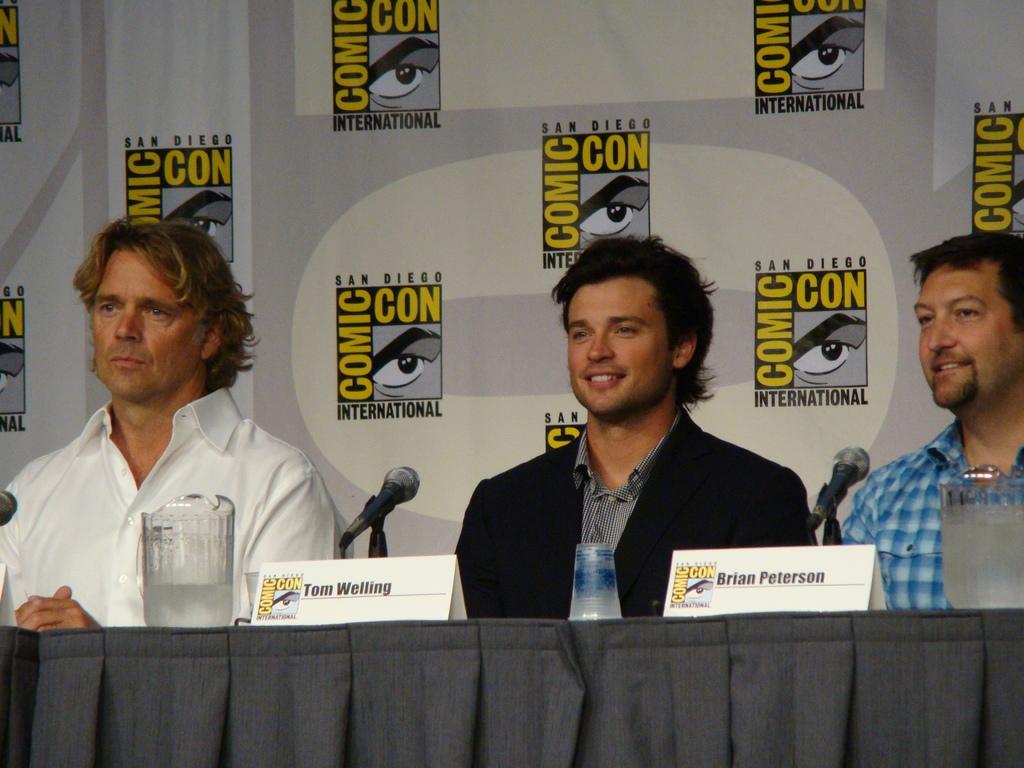Can you describe this image briefly? In this image we can see three persons sitting and there is a table in front of them and on the table we can see few mics, boards with text and some other things. In the background, we can see a poster with some text and logos. 